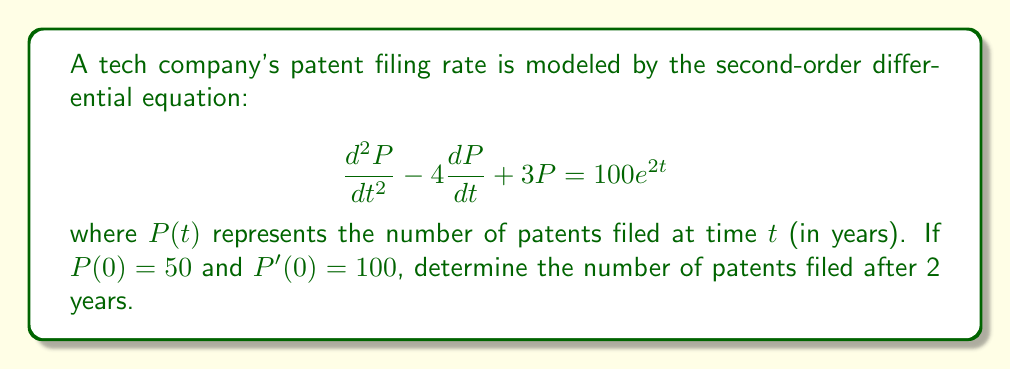Solve this math problem. To solve this problem, we need to follow these steps:

1) The general solution to this non-homogeneous second-order differential equation is the sum of the complementary function and the particular integral.

2) The complementary function (CF) is the solution to the homogeneous equation:
   $$\frac{d^2P}{dt^2} - 4\frac{dP}{dt} + 3P = 0$$
   The characteristic equation is $r^2 - 4r + 3 = 0$
   Solving this: $r = 1$ or $r = 3$
   So, the CF is: $P_c = Ae^t + Be^{3t}$

3) For the particular integral (PI), we guess a solution of the form:
   $P_p = Ce^{2t}$
   Substituting this into the original equation:
   $$(4C - 8C + 3C)e^{2t} = 100e^{2t}$$
   $$-C = 100$$
   $$C = -100$$
   So, the PI is: $P_p = -100e^{2t}$

4) The general solution is: $P = P_c + P_p = Ae^t + Be^{3t} - 100e^{2t}$

5) Using the initial conditions:
   $P(0) = 50$: $A + B - 100 = 50$
   $P'(0) = 100$: $A + 3B - 200 = 100$

6) Solving these simultaneous equations:
   $A = 225$, $B = -75$

7) Therefore, the particular solution is:
   $$P(t) = 225e^t - 75e^{3t} - 100e^{2t}$$

8) To find $P(2)$, we substitute $t = 2$:
   $$P(2) = 225e^2 - 75e^6 - 100e^4$$

9) Calculating this value:
   $$P(2) \approx 1660.59 - 33271.50 - 5411.70 \approx -37022.61$$
Answer: The number of patents filed after 2 years is approximately -37023 (rounded to the nearest integer). The negative value suggests that this model breaks down after a certain point and is not realistic for long-term predictions, which could be a point of contention in an intellectual property dispute. 